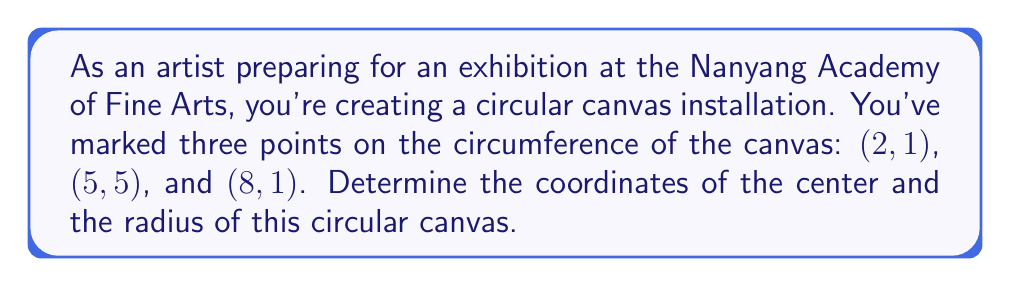Help me with this question. Let's approach this step-by-step:

1) The center of a circle is equidistant from any three points on its circumference. We can use this property to find the center.

2) Let the center be $(h, k)$. The equation of a circle is:
   $$(x - h)^2 + (y - k)^2 = r^2$$

3) Substituting our three points into this equation:
   $$(2 - h)^2 + (1 - k)^2 = r^2 \quad (1)$$
   $$(5 - h)^2 + (5 - k)^2 = r^2 \quad (2)$$
   $$(8 - h)^2 + (1 - k)^2 = r^2 \quad (3)$$

4) Subtracting equation (1) from (2) and (3):
   $$(5 - h)^2 + (5 - k)^2 = (2 - h)^2 + (1 - k)^2 \quad (4)$$
   $$(8 - h)^2 + (1 - k)^2 = (2 - h)^2 + (1 - k)^2 \quad (5)$$

5) Simplifying (4):
   $$25 - 10h + h^2 + 25 - 10k + k^2 = 4 - 4h + h^2 + 1 - 2k + k^2$$
   $$45 - 6h - 8k = 0 \quad (6)$$

6) Simplifying (5):
   $$64 - 16h + h^2 + 1 - 2k + k^2 = 4 - 4h + h^2 + 1 - 2k + k^2$$
   $$60 - 12h = 0$$
   $$h = 5 \quad (7)$$

7) Substituting (7) into (6):
   $$45 - 6(5) - 8k = 0$$
   $$45 - 30 - 8k = 0$$
   $$15 - 8k = 0$$
   $$k = \frac{15}{8} = 1.875$$

8) So, the center is $(5, 1.875)$.

9) To find the radius, substitute the center and any point into the circle equation:
   $$r^2 = (2 - 5)^2 + (1 - 1.875)^2$$
   $$r^2 = (-3)^2 + (-0.875)^2$$
   $$r^2 = 9 + 0.765625 = 9.765625$$
   $$r = \sqrt{9.765625} = 3.125$$

[asy]
import geometry;

pair A = (2,1);
pair B = (5,5);
pair C = (8,1);
pair O = (5,1.875);

draw(circle(O,3.125));
dot("A",A,SW);
dot("B",B,N);
dot("C",C,SE);
dot("O",O,S);

draw(O--A,dashed);
draw(O--B,dashed);
draw(O--C,dashed);

label("r",(O--A)/2,NW);
[/asy]
Answer: The center of the circular canvas is $(5, 1.875)$ and its radius is $3.125$ units. 